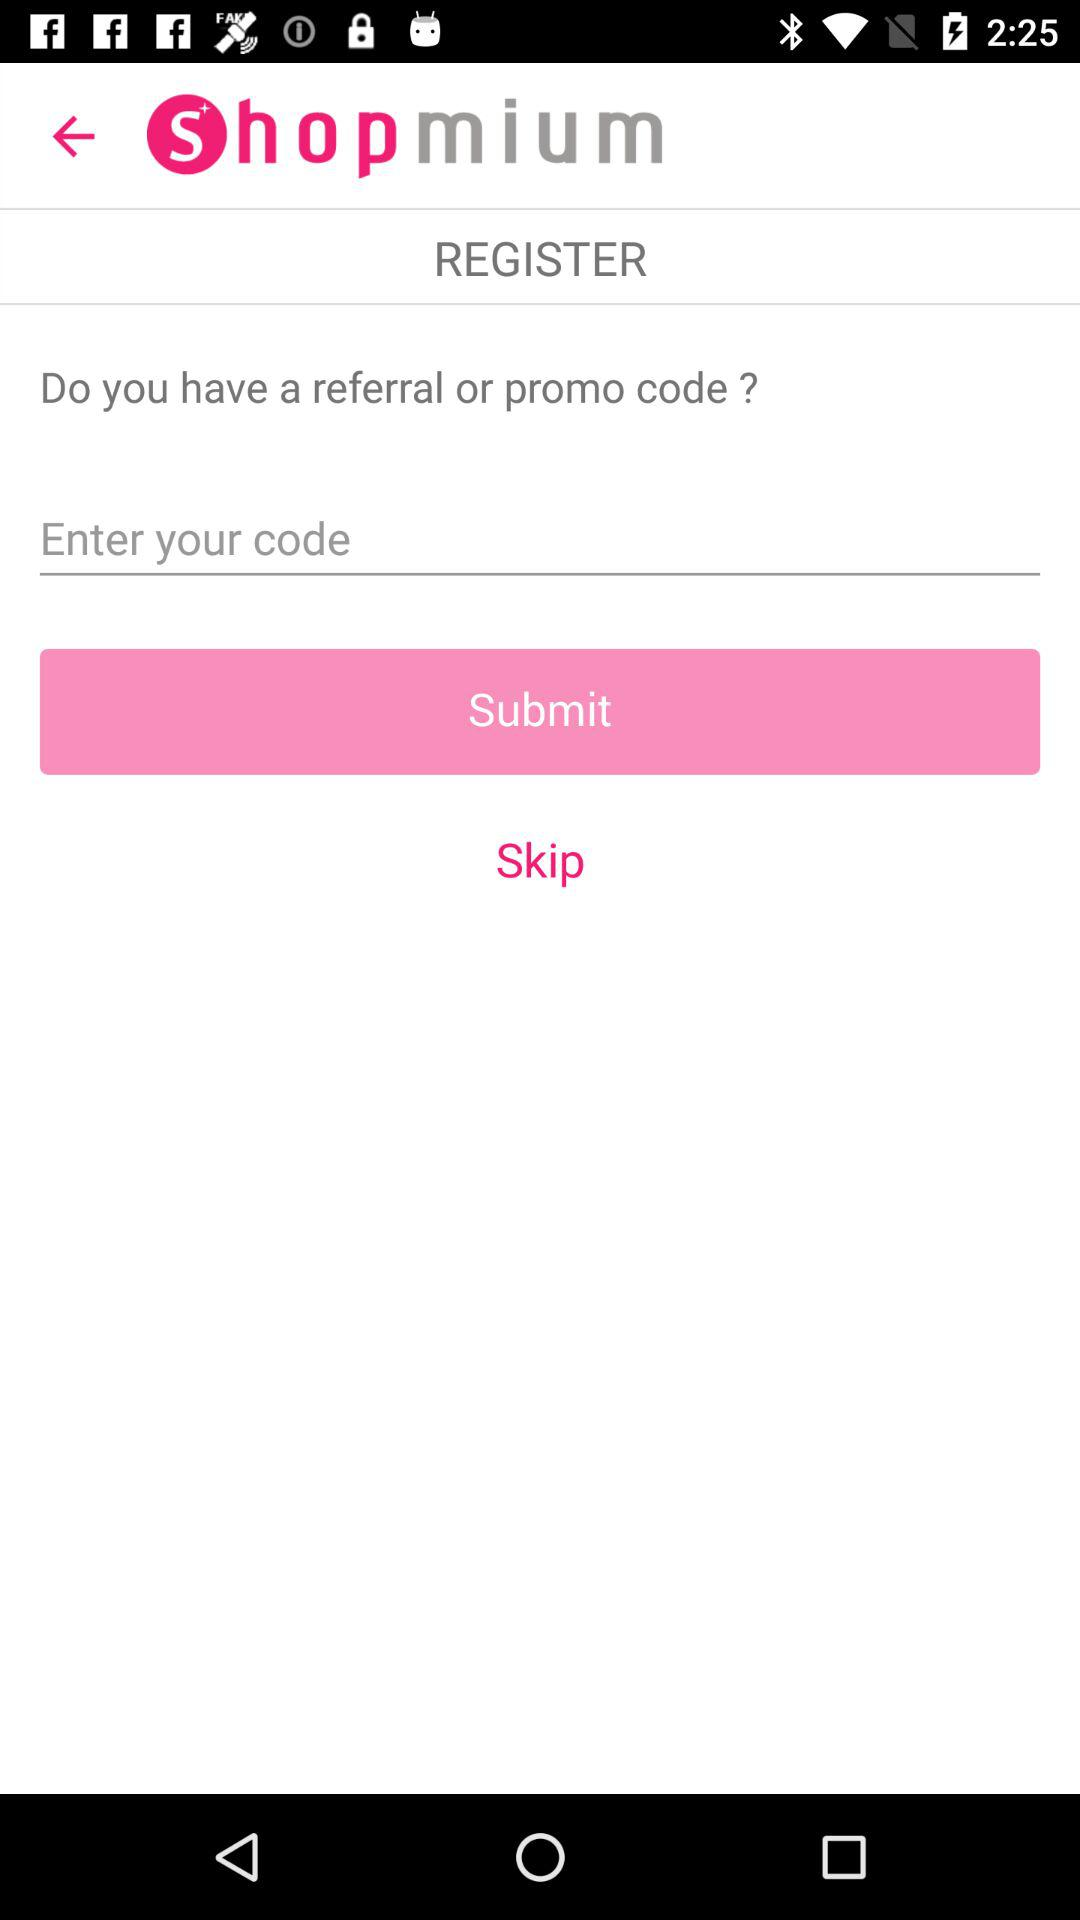What is the app's name? The app's name is "Shopmium". 